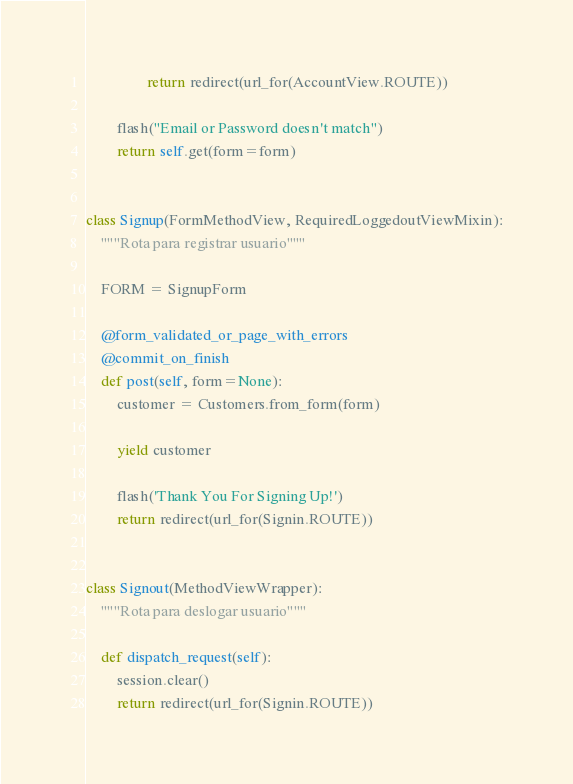Convert code to text. <code><loc_0><loc_0><loc_500><loc_500><_Python_>                return redirect(url_for(AccountView.ROUTE))
        
        flash("Email or Password doesn't match")
        return self.get(form=form)


class Signup(FormMethodView, RequiredLoggedoutViewMixin):
    """Rota para registrar usuario"""

    FORM = SignupForm

    @form_validated_or_page_with_errors
    @commit_on_finish
    def post(self, form=None):
        customer = Customers.from_form(form)
        
        yield customer

        flash('Thank You For Signing Up!')
        return redirect(url_for(Signin.ROUTE))


class Signout(MethodViewWrapper):
    """Rota para deslogar usuario"""

    def dispatch_request(self):
        session.clear()
        return redirect(url_for(Signin.ROUTE))
</code> 